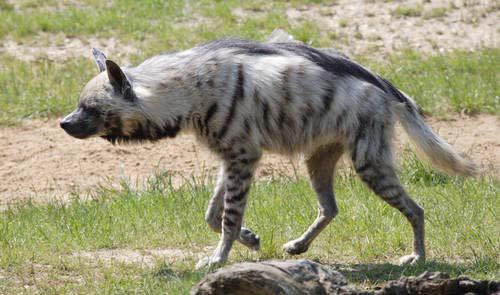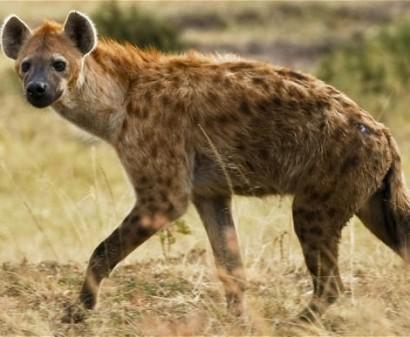The first image is the image on the left, the second image is the image on the right. For the images displayed, is the sentence "An image shows an open-mouthed lion facing off with at least one hyena." factually correct? Answer yes or no. No. The first image is the image on the left, the second image is the image on the right. Examine the images to the left and right. Is the description "At least one hyena is facing right and showing teeth." accurate? Answer yes or no. No. 